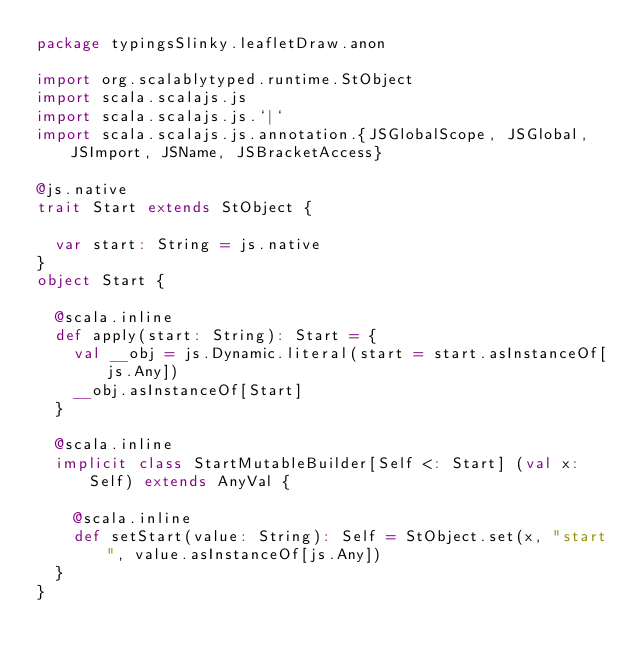<code> <loc_0><loc_0><loc_500><loc_500><_Scala_>package typingsSlinky.leafletDraw.anon

import org.scalablytyped.runtime.StObject
import scala.scalajs.js
import scala.scalajs.js.`|`
import scala.scalajs.js.annotation.{JSGlobalScope, JSGlobal, JSImport, JSName, JSBracketAccess}

@js.native
trait Start extends StObject {
  
  var start: String = js.native
}
object Start {
  
  @scala.inline
  def apply(start: String): Start = {
    val __obj = js.Dynamic.literal(start = start.asInstanceOf[js.Any])
    __obj.asInstanceOf[Start]
  }
  
  @scala.inline
  implicit class StartMutableBuilder[Self <: Start] (val x: Self) extends AnyVal {
    
    @scala.inline
    def setStart(value: String): Self = StObject.set(x, "start", value.asInstanceOf[js.Any])
  }
}
</code> 